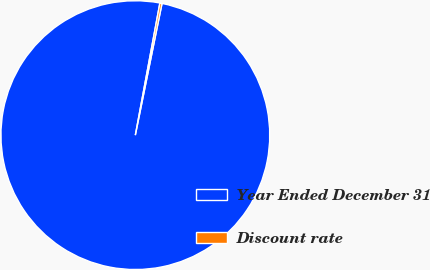Convert chart. <chart><loc_0><loc_0><loc_500><loc_500><pie_chart><fcel>Year Ended December 31<fcel>Discount rate<nl><fcel>99.74%<fcel>0.26%<nl></chart> 